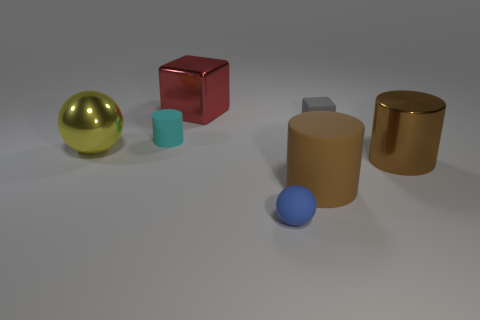Subtract all cyan cylinders. How many cylinders are left? 2 Subtract all cyan cubes. How many brown cylinders are left? 2 Add 3 big yellow balls. How many objects exist? 10 Subtract 1 cylinders. How many cylinders are left? 2 Subtract all cyan cylinders. How many cylinders are left? 2 Subtract all red cylinders. Subtract all blue blocks. How many cylinders are left? 3 Add 5 small green spheres. How many small green spheres exist? 5 Subtract 0 red cylinders. How many objects are left? 7 Subtract all spheres. How many objects are left? 5 Subtract all large yellow shiny balls. Subtract all large shiny things. How many objects are left? 3 